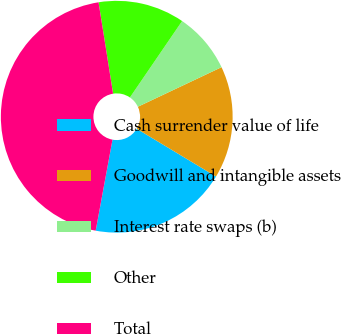Convert chart. <chart><loc_0><loc_0><loc_500><loc_500><pie_chart><fcel>Cash surrender value of life<fcel>Goodwill and intangible assets<fcel>Interest rate swaps (b)<fcel>Other<fcel>Total<nl><fcel>19.28%<fcel>15.66%<fcel>8.43%<fcel>12.05%<fcel>44.58%<nl></chart> 